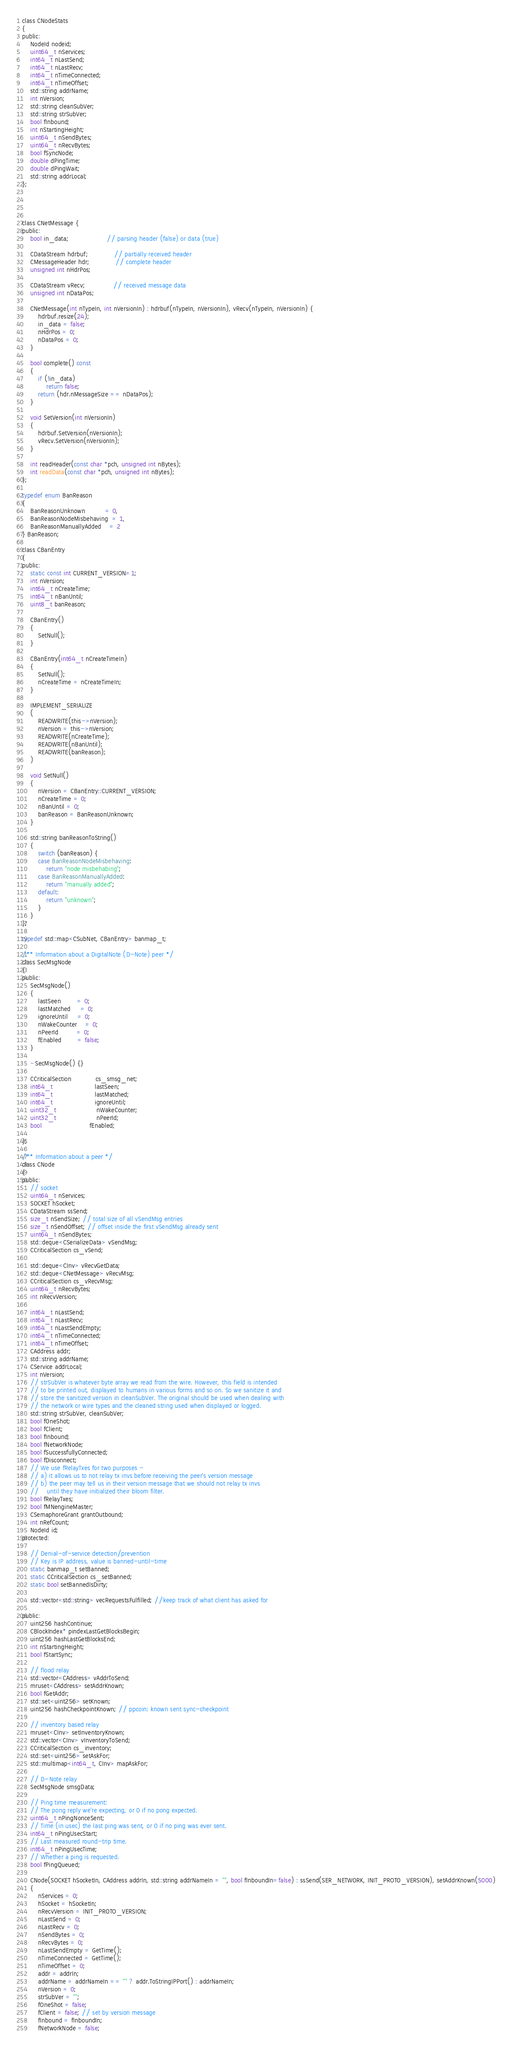<code> <loc_0><loc_0><loc_500><loc_500><_C_>class CNodeStats
{
public:
    NodeId nodeid;
    uint64_t nServices;
    int64_t nLastSend;
    int64_t nLastRecv;
    int64_t nTimeConnected;
    int64_t nTimeOffset;
    std::string addrName;
    int nVersion;
    std::string cleanSubVer;
    std::string strSubVer;
    bool fInbound;
    int nStartingHeight;
    uint64_t nSendBytes;
    uint64_t nRecvBytes;
    bool fSyncNode;
    double dPingTime;
    double dPingWait;
    std::string addrLocal;
};




class CNetMessage {
public:
    bool in_data;                   // parsing header (false) or data (true)

    CDataStream hdrbuf;             // partially received header
    CMessageHeader hdr;             // complete header
    unsigned int nHdrPos;

    CDataStream vRecv;              // received message data
    unsigned int nDataPos;

    CNetMessage(int nTypeIn, int nVersionIn) : hdrbuf(nTypeIn, nVersionIn), vRecv(nTypeIn, nVersionIn) {
        hdrbuf.resize(24);
        in_data = false;
        nHdrPos = 0;
        nDataPos = 0;
    }

    bool complete() const
    {
        if (!in_data)
            return false;
        return (hdr.nMessageSize == nDataPos);
    }

    void SetVersion(int nVersionIn)
    {
        hdrbuf.SetVersion(nVersionIn);
        vRecv.SetVersion(nVersionIn);
    }

    int readHeader(const char *pch, unsigned int nBytes);
    int readData(const char *pch, unsigned int nBytes);
};

typedef enum BanReason
{
    BanReasonUnknown          = 0,
    BanReasonNodeMisbehaving  = 1,
    BanReasonManuallyAdded    = 2
} BanReason;

class CBanEntry
{
public:
    static const int CURRENT_VERSION=1;
    int nVersion;
    int64_t nCreateTime;
    int64_t nBanUntil;
    uint8_t banReason;

    CBanEntry()
    {
        SetNull();
    }

    CBanEntry(int64_t nCreateTimeIn)
    {
        SetNull();
        nCreateTime = nCreateTimeIn;
    }
  
    IMPLEMENT_SERIALIZE
    (
        READWRITE(this->nVersion);
        nVersion = this->nVersion;
        READWRITE(nCreateTime);
        READWRITE(nBanUntil);
        READWRITE(banReason);
    )

    void SetNull()
    {
        nVersion = CBanEntry::CURRENT_VERSION;
        nCreateTime = 0;
        nBanUntil = 0;
        banReason = BanReasonUnknown;
    }

    std::string banReasonToString()
    {
        switch (banReason) {
        case BanReasonNodeMisbehaving:
            return "node misbehabing";
        case BanReasonManuallyAdded:
            return "manually added";
        default:
            return "unknown";
        }
    }
};
  
typedef std::map<CSubNet, CBanEntry> banmap_t;

/** Information about a DigitalNote (D-Note) peer */
class SecMsgNode
{
public:
    SecMsgNode()
    {
        lastSeen        = 0;
        lastMatched     = 0;
        ignoreUntil     = 0;
        nWakeCounter    = 0;
        nPeerId         = 0;
        fEnabled        = false;
    }

    ~SecMsgNode() {}

    CCriticalSection            cs_smsg_net;
    int64_t                     lastSeen;
    int64_t                     lastMatched;
    int64_t                     ignoreUntil;
    uint32_t                    nWakeCounter;
    uint32_t                    nPeerId;
    bool                        fEnabled;

};

/** Information about a peer */
class CNode
{
public:
    // socket
    uint64_t nServices;
    SOCKET hSocket;
    CDataStream ssSend;
    size_t nSendSize; // total size of all vSendMsg entries
    size_t nSendOffset; // offset inside the first vSendMsg already sent
    uint64_t nSendBytes;
    std::deque<CSerializeData> vSendMsg;
    CCriticalSection cs_vSend;

    std::deque<CInv> vRecvGetData;
    std::deque<CNetMessage> vRecvMsg;
    CCriticalSection cs_vRecvMsg;
    uint64_t nRecvBytes;
    int nRecvVersion;

    int64_t nLastSend;
    int64_t nLastRecv;
    int64_t nLastSendEmpty;
    int64_t nTimeConnected;
    int64_t nTimeOffset;
    CAddress addr;
    std::string addrName;
    CService addrLocal;
    int nVersion;
    // strSubVer is whatever byte array we read from the wire. However, this field is intended
    // to be printed out, displayed to humans in various forms and so on. So we sanitize it and
    // store the sanitized version in cleanSubVer. The original should be used when dealing with
    // the network or wire types and the cleaned string used when displayed or logged.
    std::string strSubVer, cleanSubVer;
    bool fOneShot;
    bool fClient;
    bool fInbound;
    bool fNetworkNode;
    bool fSuccessfullyConnected;
    bool fDisconnect;
    // We use fRelayTxes for two purposes -
    // a) it allows us to not relay tx invs before receiving the peer's version message
    // b) the peer may tell us in their version message that we should not relay tx invs
    //    until they have initialized their bloom filter.
    bool fRelayTxes;
    bool fMNengineMaster;
    CSemaphoreGrant grantOutbound;
    int nRefCount;
    NodeId id;
protected:

    // Denial-of-service detection/prevention
    // Key is IP address, value is banned-until-time
    static banmap_t setBanned;
    static CCriticalSection cs_setBanned;
    static bool setBannedIsDirty;

    std::vector<std::string> vecRequestsFulfilled; //keep track of what client has asked for

public:
    uint256 hashContinue;
    CBlockIndex* pindexLastGetBlocksBegin;
    uint256 hashLastGetBlocksEnd;
    int nStartingHeight;
    bool fStartSync;

    // flood relay
    std::vector<CAddress> vAddrToSend;
    mruset<CAddress> setAddrKnown;
    bool fGetAddr;
    std::set<uint256> setKnown;
    uint256 hashCheckpointKnown; // ppcoin: known sent sync-checkpoint

    // inventory based relay
    mruset<CInv> setInventoryKnown;
    std::vector<CInv> vInventoryToSend;
    CCriticalSection cs_inventory;
    std::set<uint256> setAskFor;
    std::multimap<int64_t, CInv> mapAskFor;

    // D-Note relay
    SecMsgNode smsgData;

    // Ping time measurement:
    // The pong reply we're expecting, or 0 if no pong expected.
    uint64_t nPingNonceSent;
    // Time (in usec) the last ping was sent, or 0 if no ping was ever sent.
    int64_t nPingUsecStart;
    // Last measured round-trip time.
    int64_t nPingUsecTime;
    // Whether a ping is requested.
    bool fPingQueued;

    CNode(SOCKET hSocketIn, CAddress addrIn, std::string addrNameIn = "", bool fInboundIn=false) : ssSend(SER_NETWORK, INIT_PROTO_VERSION), setAddrKnown(5000)
    {
        nServices = 0;
        hSocket = hSocketIn;
        nRecvVersion = INIT_PROTO_VERSION;
        nLastSend = 0;
        nLastRecv = 0;
        nSendBytes = 0;
        nRecvBytes = 0;
        nLastSendEmpty = GetTime();
        nTimeConnected = GetTime();
        nTimeOffset = 0;
        addr = addrIn;
        addrName = addrNameIn == "" ? addr.ToStringIPPort() : addrNameIn;
        nVersion = 0;
        strSubVer = "";
        fOneShot = false;
        fClient = false; // set by version message
        fInbound = fInboundIn;
        fNetworkNode = false;</code> 